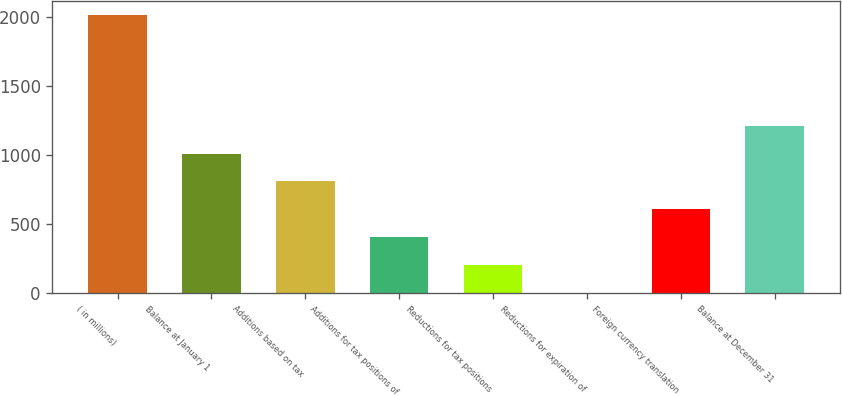Convert chart. <chart><loc_0><loc_0><loc_500><loc_500><bar_chart><fcel>( in millions)<fcel>Balance at January 1<fcel>Additions based on tax<fcel>Additions for tax positions of<fcel>Reductions for tax positions<fcel>Reductions for expiration of<fcel>Foreign currency translation<fcel>Balance at December 31<nl><fcel>2015<fcel>1008<fcel>806.6<fcel>403.8<fcel>202.4<fcel>1<fcel>605.2<fcel>1209.4<nl></chart> 